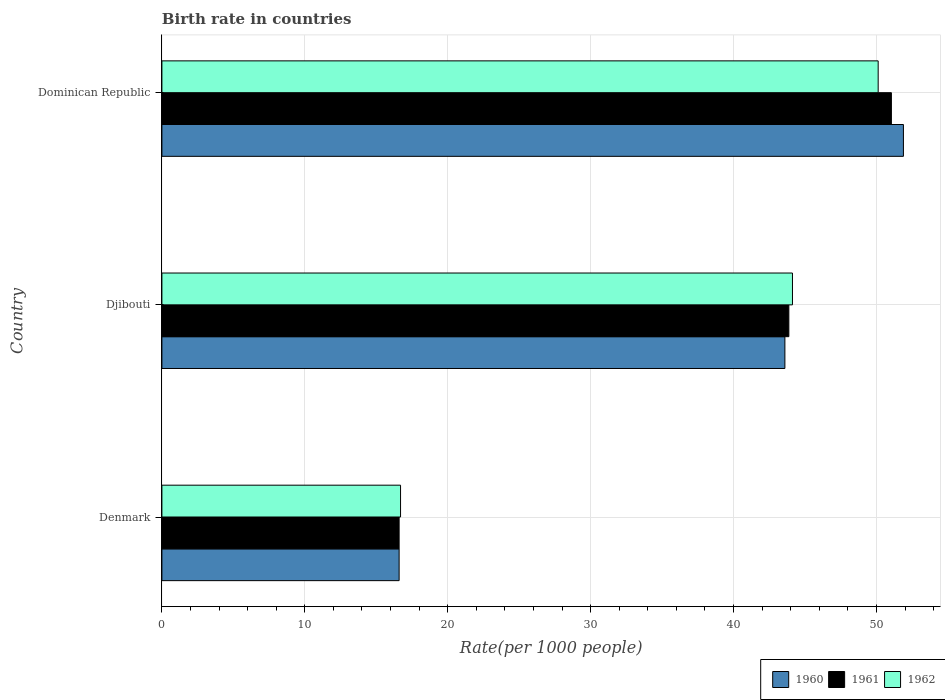How many groups of bars are there?
Ensure brevity in your answer.  3. Are the number of bars per tick equal to the number of legend labels?
Your answer should be compact. Yes. Are the number of bars on each tick of the Y-axis equal?
Offer a terse response. Yes. How many bars are there on the 3rd tick from the top?
Keep it short and to the point. 3. What is the label of the 1st group of bars from the top?
Offer a very short reply. Dominican Republic. In how many cases, is the number of bars for a given country not equal to the number of legend labels?
Make the answer very short. 0. Across all countries, what is the maximum birth rate in 1960?
Provide a short and direct response. 51.89. Across all countries, what is the minimum birth rate in 1960?
Provide a succinct answer. 16.6. In which country was the birth rate in 1961 maximum?
Make the answer very short. Dominican Republic. What is the total birth rate in 1961 in the graph?
Give a very brief answer. 111.52. What is the difference between the birth rate in 1962 in Djibouti and that in Dominican Republic?
Your response must be concise. -6. What is the difference between the birth rate in 1962 in Djibouti and the birth rate in 1960 in Dominican Republic?
Your answer should be very brief. -7.76. What is the average birth rate in 1960 per country?
Keep it short and to the point. 37.36. What is the difference between the birth rate in 1961 and birth rate in 1960 in Djibouti?
Your answer should be compact. 0.28. What is the ratio of the birth rate in 1960 in Denmark to that in Dominican Republic?
Make the answer very short. 0.32. Is the birth rate in 1960 in Denmark less than that in Dominican Republic?
Provide a succinct answer. Yes. Is the difference between the birth rate in 1961 in Denmark and Dominican Republic greater than the difference between the birth rate in 1960 in Denmark and Dominican Republic?
Your answer should be very brief. Yes. What is the difference between the highest and the second highest birth rate in 1960?
Ensure brevity in your answer.  8.29. What is the difference between the highest and the lowest birth rate in 1961?
Your response must be concise. 34.45. What does the 2nd bar from the bottom in Dominican Republic represents?
Ensure brevity in your answer.  1961. How many bars are there?
Your response must be concise. 9. Are all the bars in the graph horizontal?
Ensure brevity in your answer.  Yes. How many countries are there in the graph?
Ensure brevity in your answer.  3. What is the difference between two consecutive major ticks on the X-axis?
Make the answer very short. 10. Are the values on the major ticks of X-axis written in scientific E-notation?
Your response must be concise. No. Does the graph contain grids?
Give a very brief answer. Yes. How many legend labels are there?
Your answer should be compact. 3. How are the legend labels stacked?
Offer a very short reply. Horizontal. What is the title of the graph?
Provide a succinct answer. Birth rate in countries. Does "1993" appear as one of the legend labels in the graph?
Your answer should be compact. No. What is the label or title of the X-axis?
Provide a short and direct response. Rate(per 1000 people). What is the label or title of the Y-axis?
Make the answer very short. Country. What is the Rate(per 1000 people) in 1960 in Denmark?
Your answer should be very brief. 16.6. What is the Rate(per 1000 people) of 1961 in Denmark?
Your answer should be compact. 16.6. What is the Rate(per 1000 people) of 1962 in Denmark?
Your answer should be very brief. 16.7. What is the Rate(per 1000 people) of 1960 in Djibouti?
Offer a terse response. 43.59. What is the Rate(per 1000 people) in 1961 in Djibouti?
Give a very brief answer. 43.87. What is the Rate(per 1000 people) in 1962 in Djibouti?
Your answer should be very brief. 44.12. What is the Rate(per 1000 people) of 1960 in Dominican Republic?
Ensure brevity in your answer.  51.89. What is the Rate(per 1000 people) in 1961 in Dominican Republic?
Your answer should be compact. 51.05. What is the Rate(per 1000 people) in 1962 in Dominican Republic?
Your answer should be very brief. 50.12. Across all countries, what is the maximum Rate(per 1000 people) in 1960?
Keep it short and to the point. 51.89. Across all countries, what is the maximum Rate(per 1000 people) in 1961?
Give a very brief answer. 51.05. Across all countries, what is the maximum Rate(per 1000 people) of 1962?
Your answer should be very brief. 50.12. Across all countries, what is the minimum Rate(per 1000 people) in 1960?
Offer a very short reply. 16.6. What is the total Rate(per 1000 people) in 1960 in the graph?
Provide a succinct answer. 112.08. What is the total Rate(per 1000 people) in 1961 in the graph?
Ensure brevity in your answer.  111.52. What is the total Rate(per 1000 people) in 1962 in the graph?
Offer a very short reply. 110.95. What is the difference between the Rate(per 1000 people) of 1960 in Denmark and that in Djibouti?
Keep it short and to the point. -27. What is the difference between the Rate(per 1000 people) in 1961 in Denmark and that in Djibouti?
Provide a succinct answer. -27.27. What is the difference between the Rate(per 1000 people) in 1962 in Denmark and that in Djibouti?
Your answer should be very brief. -27.43. What is the difference between the Rate(per 1000 people) of 1960 in Denmark and that in Dominican Republic?
Provide a short and direct response. -35.29. What is the difference between the Rate(per 1000 people) of 1961 in Denmark and that in Dominican Republic?
Ensure brevity in your answer.  -34.45. What is the difference between the Rate(per 1000 people) of 1962 in Denmark and that in Dominican Republic?
Provide a succinct answer. -33.42. What is the difference between the Rate(per 1000 people) of 1960 in Djibouti and that in Dominican Republic?
Your answer should be very brief. -8.29. What is the difference between the Rate(per 1000 people) in 1961 in Djibouti and that in Dominican Republic?
Offer a very short reply. -7.18. What is the difference between the Rate(per 1000 people) in 1962 in Djibouti and that in Dominican Republic?
Keep it short and to the point. -6. What is the difference between the Rate(per 1000 people) of 1960 in Denmark and the Rate(per 1000 people) of 1961 in Djibouti?
Give a very brief answer. -27.27. What is the difference between the Rate(per 1000 people) of 1960 in Denmark and the Rate(per 1000 people) of 1962 in Djibouti?
Offer a very short reply. -27.52. What is the difference between the Rate(per 1000 people) in 1961 in Denmark and the Rate(per 1000 people) in 1962 in Djibouti?
Keep it short and to the point. -27.52. What is the difference between the Rate(per 1000 people) of 1960 in Denmark and the Rate(per 1000 people) of 1961 in Dominican Republic?
Provide a short and direct response. -34.45. What is the difference between the Rate(per 1000 people) of 1960 in Denmark and the Rate(per 1000 people) of 1962 in Dominican Republic?
Your response must be concise. -33.52. What is the difference between the Rate(per 1000 people) of 1961 in Denmark and the Rate(per 1000 people) of 1962 in Dominican Republic?
Offer a very short reply. -33.52. What is the difference between the Rate(per 1000 people) of 1960 in Djibouti and the Rate(per 1000 people) of 1961 in Dominican Republic?
Your response must be concise. -7.45. What is the difference between the Rate(per 1000 people) of 1960 in Djibouti and the Rate(per 1000 people) of 1962 in Dominican Republic?
Your response must be concise. -6.53. What is the difference between the Rate(per 1000 people) in 1961 in Djibouti and the Rate(per 1000 people) in 1962 in Dominican Republic?
Provide a short and direct response. -6.25. What is the average Rate(per 1000 people) of 1960 per country?
Your answer should be compact. 37.36. What is the average Rate(per 1000 people) in 1961 per country?
Make the answer very short. 37.17. What is the average Rate(per 1000 people) of 1962 per country?
Your answer should be compact. 36.98. What is the difference between the Rate(per 1000 people) of 1960 and Rate(per 1000 people) of 1961 in Denmark?
Offer a terse response. 0. What is the difference between the Rate(per 1000 people) of 1960 and Rate(per 1000 people) of 1962 in Denmark?
Provide a short and direct response. -0.1. What is the difference between the Rate(per 1000 people) of 1960 and Rate(per 1000 people) of 1961 in Djibouti?
Your answer should be very brief. -0.28. What is the difference between the Rate(per 1000 people) in 1960 and Rate(per 1000 people) in 1962 in Djibouti?
Offer a terse response. -0.53. What is the difference between the Rate(per 1000 people) in 1961 and Rate(per 1000 people) in 1962 in Djibouti?
Your answer should be very brief. -0.25. What is the difference between the Rate(per 1000 people) in 1960 and Rate(per 1000 people) in 1961 in Dominican Republic?
Your answer should be very brief. 0.84. What is the difference between the Rate(per 1000 people) of 1960 and Rate(per 1000 people) of 1962 in Dominican Republic?
Your answer should be compact. 1.77. What is the difference between the Rate(per 1000 people) in 1961 and Rate(per 1000 people) in 1962 in Dominican Republic?
Ensure brevity in your answer.  0.93. What is the ratio of the Rate(per 1000 people) of 1960 in Denmark to that in Djibouti?
Offer a very short reply. 0.38. What is the ratio of the Rate(per 1000 people) of 1961 in Denmark to that in Djibouti?
Your answer should be very brief. 0.38. What is the ratio of the Rate(per 1000 people) of 1962 in Denmark to that in Djibouti?
Provide a short and direct response. 0.38. What is the ratio of the Rate(per 1000 people) in 1960 in Denmark to that in Dominican Republic?
Offer a very short reply. 0.32. What is the ratio of the Rate(per 1000 people) in 1961 in Denmark to that in Dominican Republic?
Your answer should be very brief. 0.33. What is the ratio of the Rate(per 1000 people) of 1962 in Denmark to that in Dominican Republic?
Make the answer very short. 0.33. What is the ratio of the Rate(per 1000 people) of 1960 in Djibouti to that in Dominican Republic?
Provide a succinct answer. 0.84. What is the ratio of the Rate(per 1000 people) of 1961 in Djibouti to that in Dominican Republic?
Keep it short and to the point. 0.86. What is the ratio of the Rate(per 1000 people) in 1962 in Djibouti to that in Dominican Republic?
Keep it short and to the point. 0.88. What is the difference between the highest and the second highest Rate(per 1000 people) in 1960?
Offer a terse response. 8.29. What is the difference between the highest and the second highest Rate(per 1000 people) in 1961?
Provide a succinct answer. 7.18. What is the difference between the highest and the second highest Rate(per 1000 people) in 1962?
Provide a succinct answer. 6. What is the difference between the highest and the lowest Rate(per 1000 people) in 1960?
Provide a short and direct response. 35.29. What is the difference between the highest and the lowest Rate(per 1000 people) of 1961?
Provide a short and direct response. 34.45. What is the difference between the highest and the lowest Rate(per 1000 people) in 1962?
Keep it short and to the point. 33.42. 